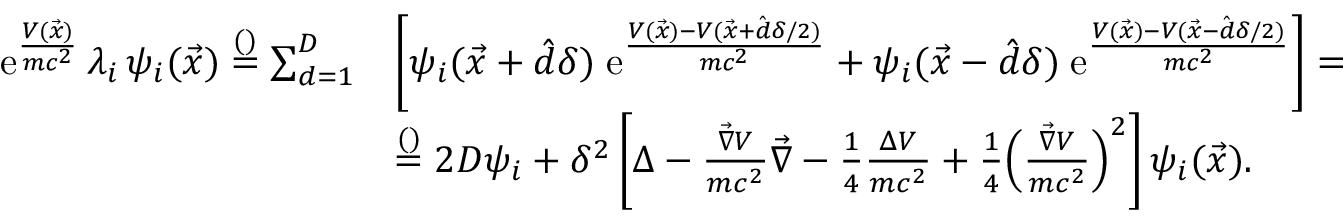<formula> <loc_0><loc_0><loc_500><loc_500>\begin{array} { r l } { \mathrm e ^ { \frac { V ( \vec { x } ) } { m c ^ { 2 } } } \, \lambda _ { i } \, \psi _ { i } ( \vec { x } ) \overset { ( ) } { = } \sum _ { d = 1 } ^ { D } } & { \left [ \psi _ { i } ( \vec { x } + \hat { d } \delta ) \, \mathrm e ^ { \frac { V ( \vec { x } ) - V ( \vec { x } + \hat { d } \delta / 2 ) } { m c ^ { 2 } } } + \psi _ { i } ( \vec { x } - \hat { d } \delta ) \, \mathrm e ^ { \frac { V ( \vec { x } ) - V ( \vec { x } - \hat { d } \delta / 2 ) } { m c ^ { 2 } } } \right ] = } \\ & { \overset { ( ) } { = } 2 D \psi _ { i } + \delta ^ { 2 } \left [ \Delta - \frac { \vec { \nabla } V } { m c ^ { 2 } } \vec { \nabla } - \frac { 1 } { 4 } \frac { \Delta V } { m c ^ { 2 } } + \frac { 1 } { 4 } \left ( \frac { \vec { \nabla } V } { m c ^ { 2 } } \right ) ^ { 2 } \right ] \psi _ { i } ( \vec { x } ) . } \end{array}</formula> 